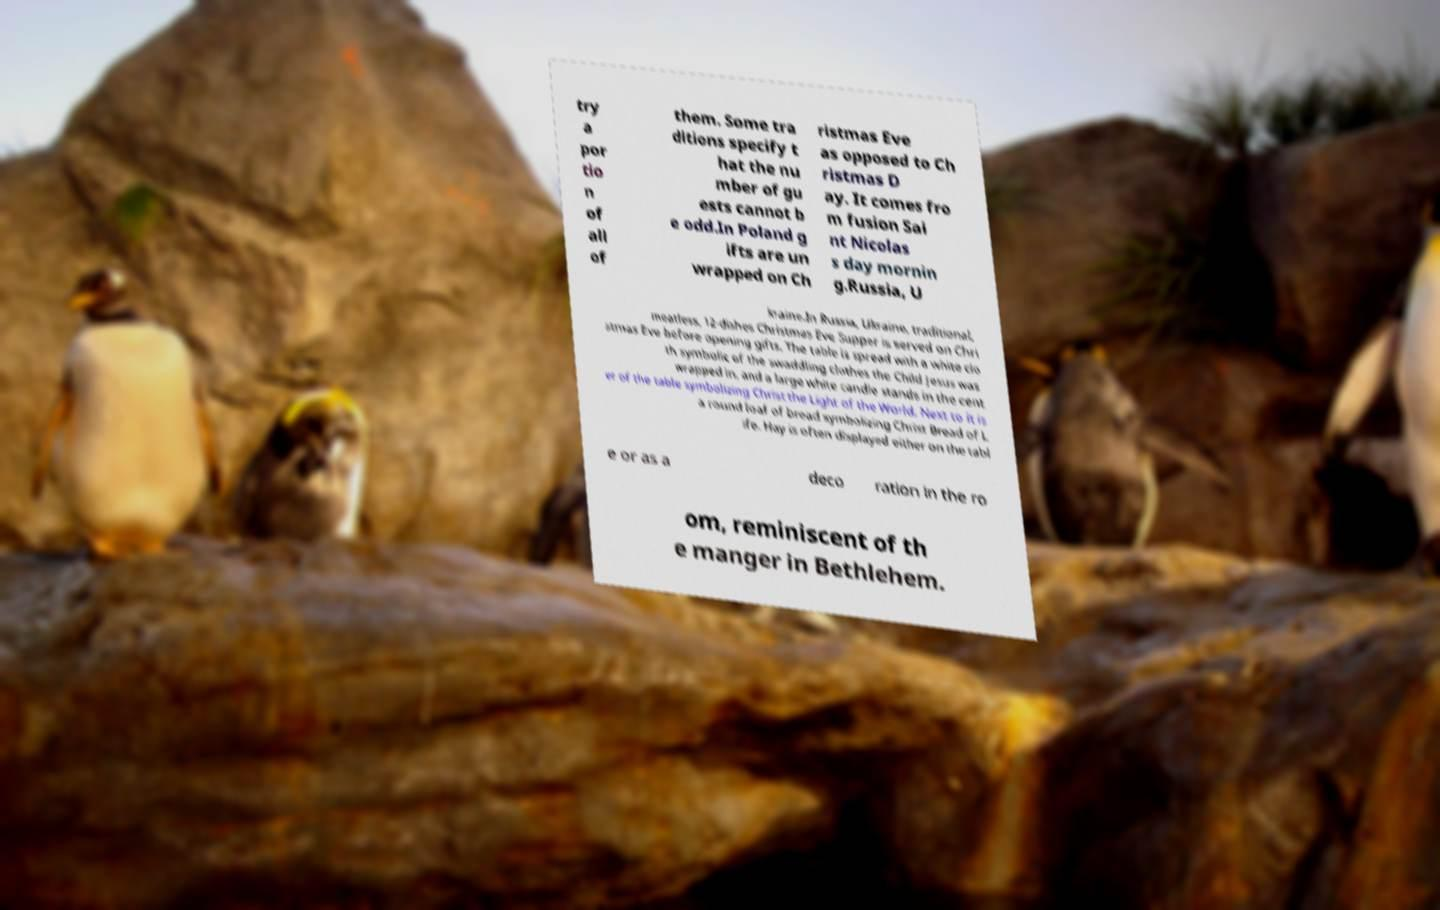Can you accurately transcribe the text from the provided image for me? try a por tio n of all of them. Some tra ditions specify t hat the nu mber of gu ests cannot b e odd.In Poland g ifts are un wrapped on Ch ristmas Eve as opposed to Ch ristmas D ay. It comes fro m fusion Sai nt Nicolas s day mornin g.Russia, U kraine.In Russia, Ukraine, traditional, meatless, 12-dishes Christmas Eve Supper is served on Chri stmas Eve before opening gifts. The table is spread with a white clo th symbolic of the swaddling clothes the Child Jesus was wrapped in, and a large white candle stands in the cent er of the table symbolizing Christ the Light of the World. Next to it is a round loaf of bread symbolizing Christ Bread of L ife. Hay is often displayed either on the tabl e or as a deco ration in the ro om, reminiscent of th e manger in Bethlehem. 